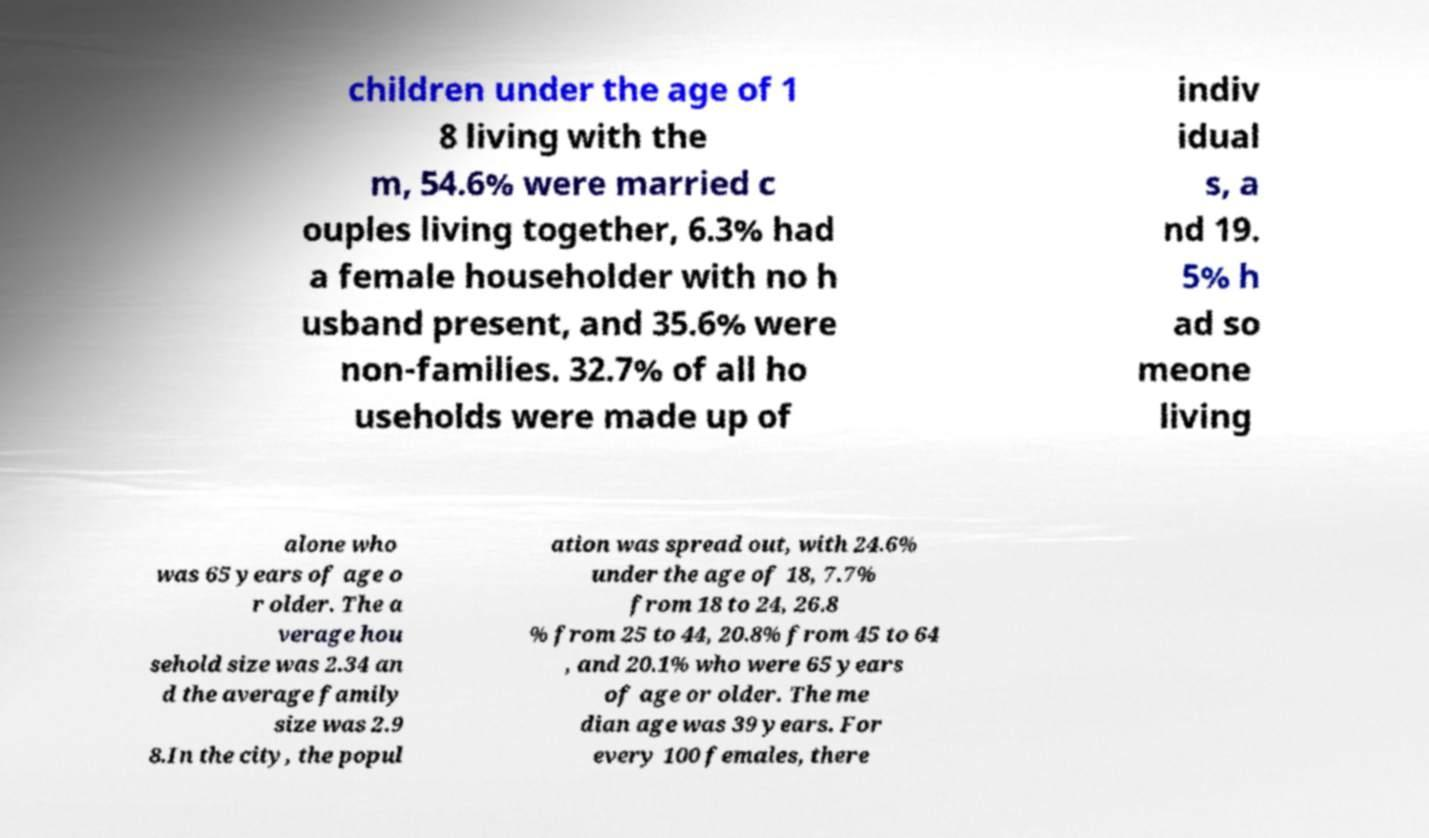For documentation purposes, I need the text within this image transcribed. Could you provide that? children under the age of 1 8 living with the m, 54.6% were married c ouples living together, 6.3% had a female householder with no h usband present, and 35.6% were non-families. 32.7% of all ho useholds were made up of indiv idual s, a nd 19. 5% h ad so meone living alone who was 65 years of age o r older. The a verage hou sehold size was 2.34 an d the average family size was 2.9 8.In the city, the popul ation was spread out, with 24.6% under the age of 18, 7.7% from 18 to 24, 26.8 % from 25 to 44, 20.8% from 45 to 64 , and 20.1% who were 65 years of age or older. The me dian age was 39 years. For every 100 females, there 